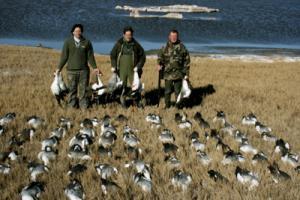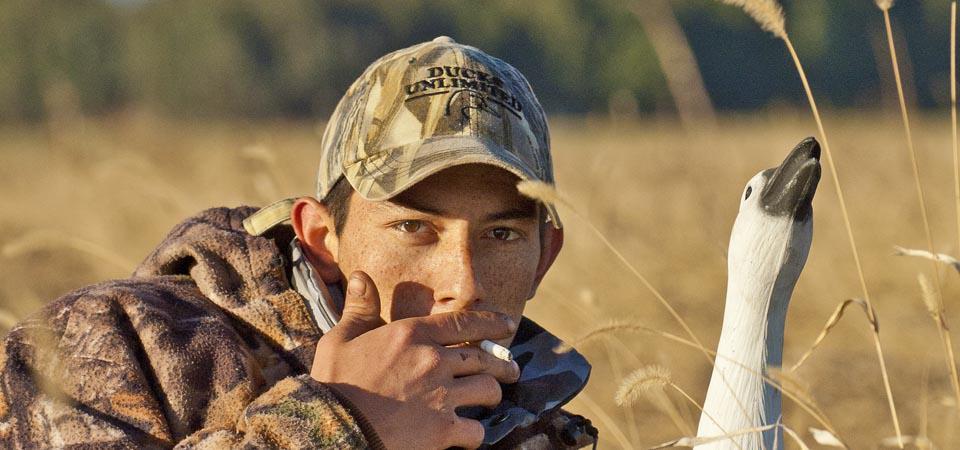The first image is the image on the left, the second image is the image on the right. Assess this claim about the two images: "An image includes at least one hunter, dog and many dead birds.". Correct or not? Answer yes or no. No. The first image is the image on the left, the second image is the image on the right. Considering the images on both sides, is "One of the photos contains one or more dogs." valid? Answer yes or no. No. 